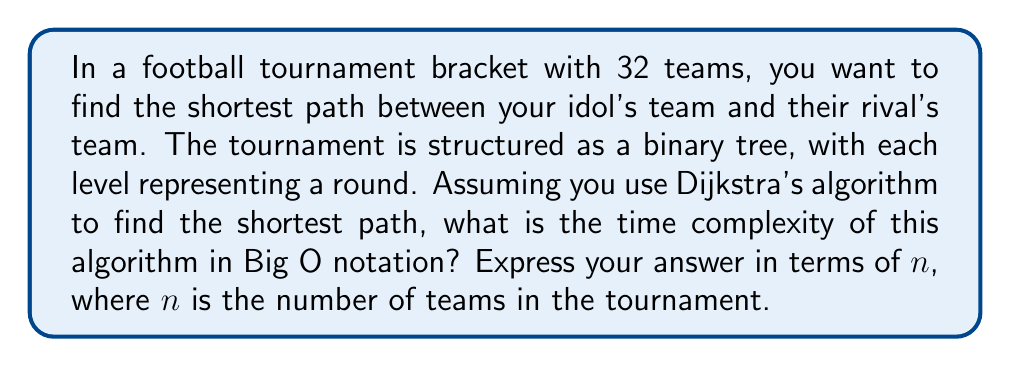Provide a solution to this math problem. Let's approach this step-by-step:

1) First, we need to understand the structure of the problem:
   - We have a binary tree representing the tournament bracket.
   - There are 32 teams, which means the tree has $\log_2(32) = 5$ levels.

2) In Dijkstra's algorithm, the time complexity depends on the number of vertices (V) and edges (E) in the graph:
   - Time complexity of Dijkstra's: $O((V + E) \log V)$

3) In our binary tree:
   - The number of vertices (V) is equal to the number of teams, so $V = 32 = n$
   - The number of edges (E) in a binary tree is always one less than the number of vertices, so $E = 31 = n - 1$

4) Substituting these into our time complexity formula:
   $O((n + (n-1)) \log n)$

5) Simplifying:
   $O((2n - 1) \log n)$
   $O(2n \log n - \log n)$

6) In Big O notation, we only care about the highest order term, so we can drop the $-\log n$:
   $O(2n \log n)$

7) Constants don't affect Big O notation, so we can remove the 2:
   $O(n \log n)$

Therefore, the time complexity of using Dijkstra's algorithm to find the shortest path in this tournament bracket is $O(n \log n)$.
Answer: $O(n \log n)$ 